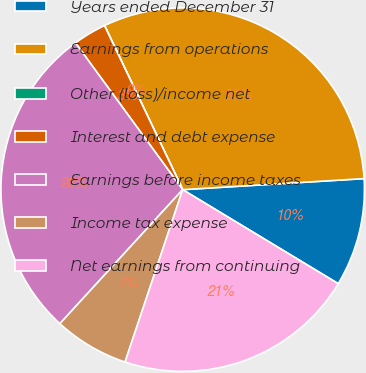Convert chart to OTSL. <chart><loc_0><loc_0><loc_500><loc_500><pie_chart><fcel>Years ended December 31<fcel>Earnings from operations<fcel>Other (loss)/income net<fcel>Interest and debt expense<fcel>Earnings before income taxes<fcel>Income tax expense<fcel>Net earnings from continuing<nl><fcel>9.62%<fcel>31.1%<fcel>0.01%<fcel>2.96%<fcel>28.15%<fcel>6.67%<fcel>21.48%<nl></chart> 